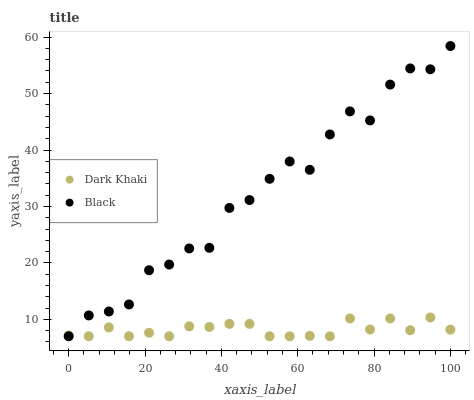Does Dark Khaki have the minimum area under the curve?
Answer yes or no. Yes. Does Black have the maximum area under the curve?
Answer yes or no. Yes. Does Black have the minimum area under the curve?
Answer yes or no. No. Is Dark Khaki the smoothest?
Answer yes or no. Yes. Is Black the roughest?
Answer yes or no. Yes. Is Black the smoothest?
Answer yes or no. No. Does Dark Khaki have the lowest value?
Answer yes or no. Yes. Does Black have the highest value?
Answer yes or no. Yes. Does Dark Khaki intersect Black?
Answer yes or no. Yes. Is Dark Khaki less than Black?
Answer yes or no. No. Is Dark Khaki greater than Black?
Answer yes or no. No. 